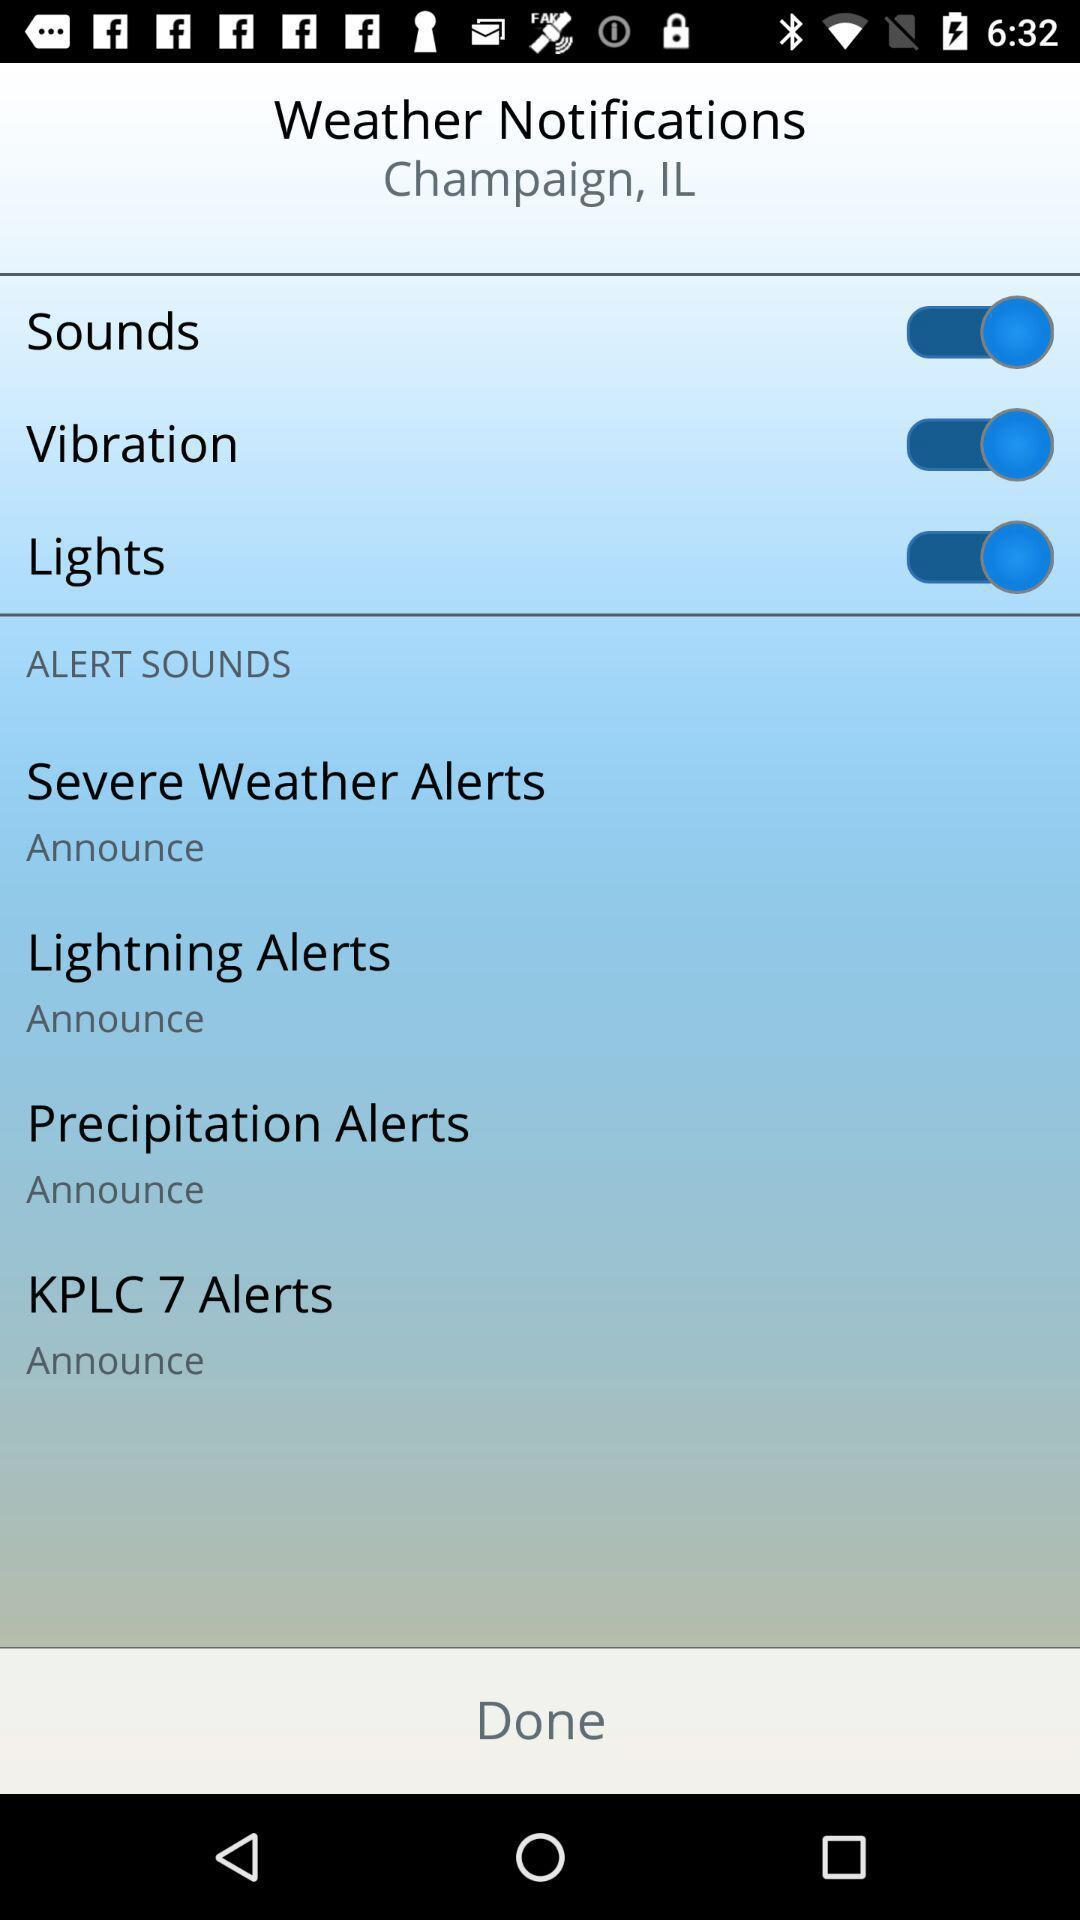How many alert sounds are available?
Answer the question using a single word or phrase. 4 